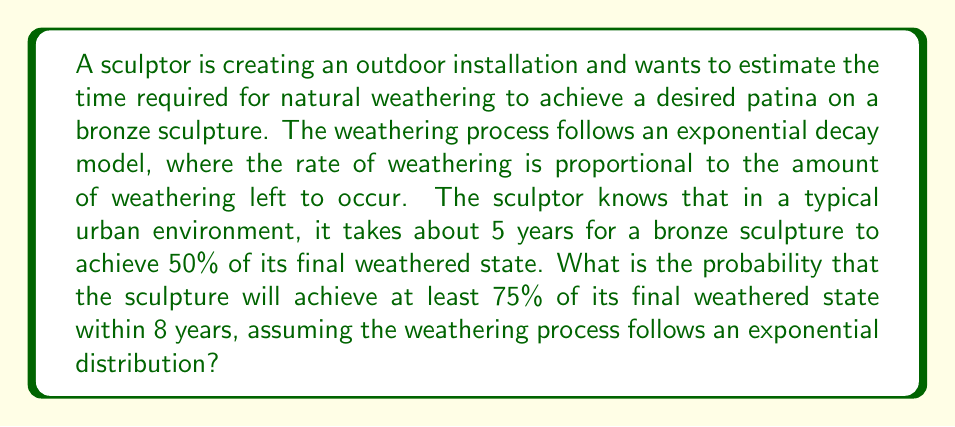Help me with this question. Let's approach this step-by-step:

1) First, we need to determine the rate parameter λ of the exponential distribution. We know that after 5 years, 50% of the weathering has occurred. This can be expressed as:

   $$1 - e^{-5λ} = 0.5$$

2) Solving for λ:

   $$e^{-5λ} = 0.5$$
   $$-5λ = ln(0.5)$$
   $$λ = -\frac{ln(0.5)}{5} ≈ 0.1386$$

3) Now, we want to find the probability that the sculpture will achieve at least 75% of its final weathered state within 8 years. This is equivalent to finding the probability that it will take 8 years or less to reach 75% weathering.

4) We can express this as:

   $$P(X ≤ 8) = 1 - e^{-8λ}$$

   where X is the time to reach 75% weathering.

5) However, we need to adjust our λ because it was calculated for 50% weathering. For 75% weathering, we need to solve:

   $$1 - e^{-tλ} = 0.75$$
   $$e^{-tλ} = 0.25$$
   $$-tλ = ln(0.25)$$
   $$t = -\frac{ln(0.25)}{λ} ≈ 9.96$$

6) This means that it takes about 9.96 years to reach 75% weathering on average.

7) Now we can calculate the probability:

   $$P(X ≤ 8) = 1 - e^{-8 * (1/9.96)} ≈ 1 - e^{-0.8032} ≈ 0.5521$$

Therefore, the probability that the sculpture will achieve at least 75% of its final weathered state within 8 years is approximately 0.5521 or 55.21%.
Answer: 0.5521 